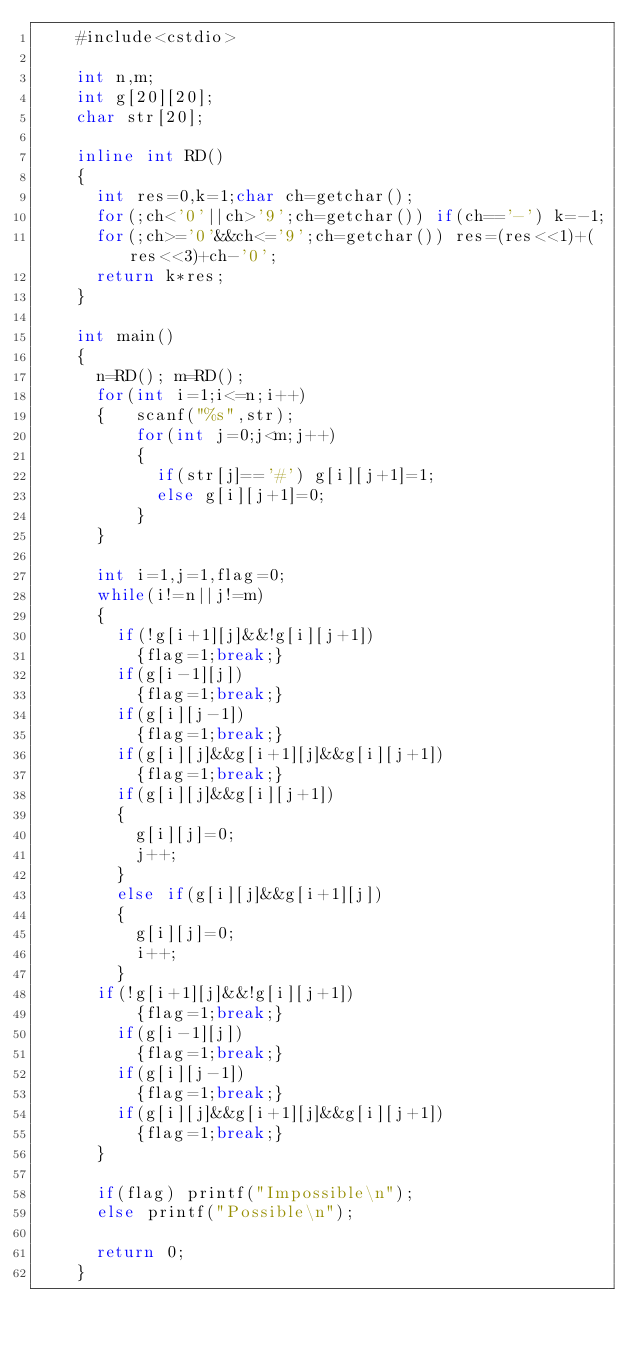<code> <loc_0><loc_0><loc_500><loc_500><_C++_>    #include<cstdio>
     
    int n,m;
    int g[20][20];
    char str[20];
     
    inline int RD()
    {
    	int res=0,k=1;char ch=getchar();
    	for(;ch<'0'||ch>'9';ch=getchar()) if(ch=='-') k=-1;
    	for(;ch>='0'&&ch<='9';ch=getchar()) res=(res<<1)+(res<<3)+ch-'0';
    	return k*res;
    }
     
    int main()
    {
    	n=RD(); m=RD();
    	for(int i=1;i<=n;i++)
    	{		scanf("%s",str);
    			for(int j=0;j<m;j++)
    			{
    				if(str[j]=='#') g[i][j+1]=1;
    				else g[i][j+1]=0;
    			}
    	}
    	
    	int i=1,j=1,flag=0;
    	while(i!=n||j!=m)
    	{
    		if(!g[i+1][j]&&!g[i][j+1])
    			{flag=1;break;}
    		if(g[i-1][j])
    			{flag=1;break;}
    		if(g[i][j-1])
    			{flag=1;break;}
    		if(g[i][j]&&g[i+1][j]&&g[i][j+1])
    			{flag=1;break;}
    		if(g[i][j]&&g[i][j+1])
    		{
    			g[i][j]=0;
    			j++;
    		}
    		else if(g[i][j]&&g[i+1][j])
    		{
    			g[i][j]=0;
    			i++;
    		}
			if(!g[i+1][j]&&!g[i][j+1])
    			{flag=1;break;}
    		if(g[i-1][j])
    			{flag=1;break;}
    		if(g[i][j-1])
    			{flag=1;break;}
    		if(g[i][j]&&g[i+1][j]&&g[i][j+1])
    			{flag=1;break;}
    	}
     
    	if(flag) printf("Impossible\n");
    	else printf("Possible\n");
     
    	return 0;
    }
	
	</code> 